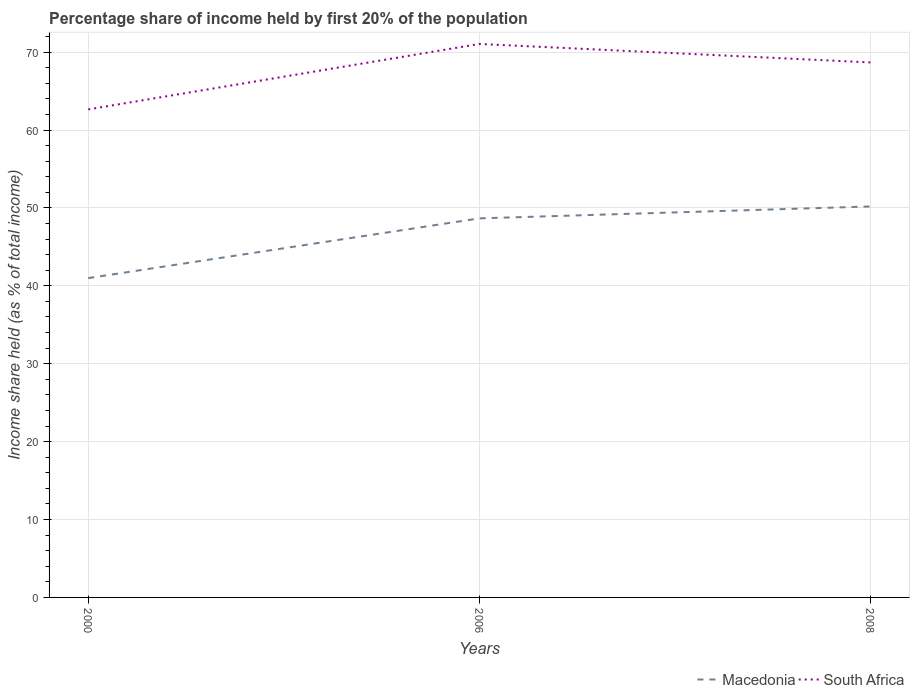Does the line corresponding to Macedonia intersect with the line corresponding to South Africa?
Provide a short and direct response. No. Is the number of lines equal to the number of legend labels?
Your response must be concise. Yes. Across all years, what is the maximum share of income held by first 20% of the population in South Africa?
Your answer should be very brief. 62.65. What is the total share of income held by first 20% of the population in South Africa in the graph?
Keep it short and to the point. -8.4. What is the difference between the highest and the second highest share of income held by first 20% of the population in Macedonia?
Keep it short and to the point. 9.2. How many years are there in the graph?
Your answer should be very brief. 3. Does the graph contain grids?
Keep it short and to the point. Yes. How are the legend labels stacked?
Make the answer very short. Horizontal. What is the title of the graph?
Keep it short and to the point. Percentage share of income held by first 20% of the population. What is the label or title of the X-axis?
Offer a terse response. Years. What is the label or title of the Y-axis?
Provide a short and direct response. Income share held (as % of total income). What is the Income share held (as % of total income) of Macedonia in 2000?
Offer a very short reply. 40.99. What is the Income share held (as % of total income) in South Africa in 2000?
Offer a terse response. 62.65. What is the Income share held (as % of total income) of Macedonia in 2006?
Keep it short and to the point. 48.66. What is the Income share held (as % of total income) of South Africa in 2006?
Your answer should be very brief. 71.05. What is the Income share held (as % of total income) of Macedonia in 2008?
Ensure brevity in your answer.  50.19. What is the Income share held (as % of total income) of South Africa in 2008?
Provide a succinct answer. 68.68. Across all years, what is the maximum Income share held (as % of total income) of Macedonia?
Your answer should be compact. 50.19. Across all years, what is the maximum Income share held (as % of total income) of South Africa?
Give a very brief answer. 71.05. Across all years, what is the minimum Income share held (as % of total income) of Macedonia?
Your response must be concise. 40.99. Across all years, what is the minimum Income share held (as % of total income) of South Africa?
Provide a short and direct response. 62.65. What is the total Income share held (as % of total income) in Macedonia in the graph?
Your answer should be compact. 139.84. What is the total Income share held (as % of total income) of South Africa in the graph?
Your answer should be compact. 202.38. What is the difference between the Income share held (as % of total income) in Macedonia in 2000 and that in 2006?
Your response must be concise. -7.67. What is the difference between the Income share held (as % of total income) of South Africa in 2000 and that in 2006?
Make the answer very short. -8.4. What is the difference between the Income share held (as % of total income) of South Africa in 2000 and that in 2008?
Provide a short and direct response. -6.03. What is the difference between the Income share held (as % of total income) of Macedonia in 2006 and that in 2008?
Provide a short and direct response. -1.53. What is the difference between the Income share held (as % of total income) of South Africa in 2006 and that in 2008?
Offer a terse response. 2.37. What is the difference between the Income share held (as % of total income) in Macedonia in 2000 and the Income share held (as % of total income) in South Africa in 2006?
Your response must be concise. -30.06. What is the difference between the Income share held (as % of total income) of Macedonia in 2000 and the Income share held (as % of total income) of South Africa in 2008?
Offer a very short reply. -27.69. What is the difference between the Income share held (as % of total income) in Macedonia in 2006 and the Income share held (as % of total income) in South Africa in 2008?
Your answer should be very brief. -20.02. What is the average Income share held (as % of total income) of Macedonia per year?
Provide a short and direct response. 46.61. What is the average Income share held (as % of total income) of South Africa per year?
Offer a very short reply. 67.46. In the year 2000, what is the difference between the Income share held (as % of total income) of Macedonia and Income share held (as % of total income) of South Africa?
Provide a succinct answer. -21.66. In the year 2006, what is the difference between the Income share held (as % of total income) in Macedonia and Income share held (as % of total income) in South Africa?
Offer a terse response. -22.39. In the year 2008, what is the difference between the Income share held (as % of total income) in Macedonia and Income share held (as % of total income) in South Africa?
Ensure brevity in your answer.  -18.49. What is the ratio of the Income share held (as % of total income) of Macedonia in 2000 to that in 2006?
Your answer should be very brief. 0.84. What is the ratio of the Income share held (as % of total income) of South Africa in 2000 to that in 2006?
Provide a succinct answer. 0.88. What is the ratio of the Income share held (as % of total income) in Macedonia in 2000 to that in 2008?
Provide a short and direct response. 0.82. What is the ratio of the Income share held (as % of total income) of South Africa in 2000 to that in 2008?
Keep it short and to the point. 0.91. What is the ratio of the Income share held (as % of total income) of Macedonia in 2006 to that in 2008?
Provide a succinct answer. 0.97. What is the ratio of the Income share held (as % of total income) in South Africa in 2006 to that in 2008?
Offer a terse response. 1.03. What is the difference between the highest and the second highest Income share held (as % of total income) of Macedonia?
Keep it short and to the point. 1.53. What is the difference between the highest and the second highest Income share held (as % of total income) of South Africa?
Provide a succinct answer. 2.37. What is the difference between the highest and the lowest Income share held (as % of total income) of Macedonia?
Your response must be concise. 9.2. 